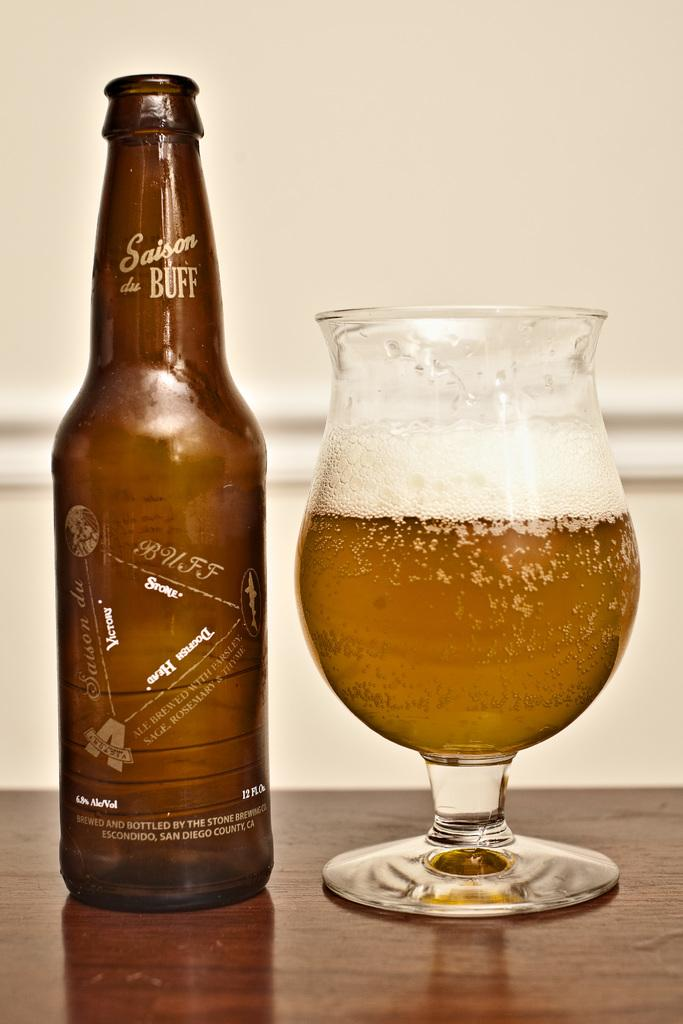<image>
Create a compact narrative representing the image presented. A bottle with the word buff on it next to a glass. 